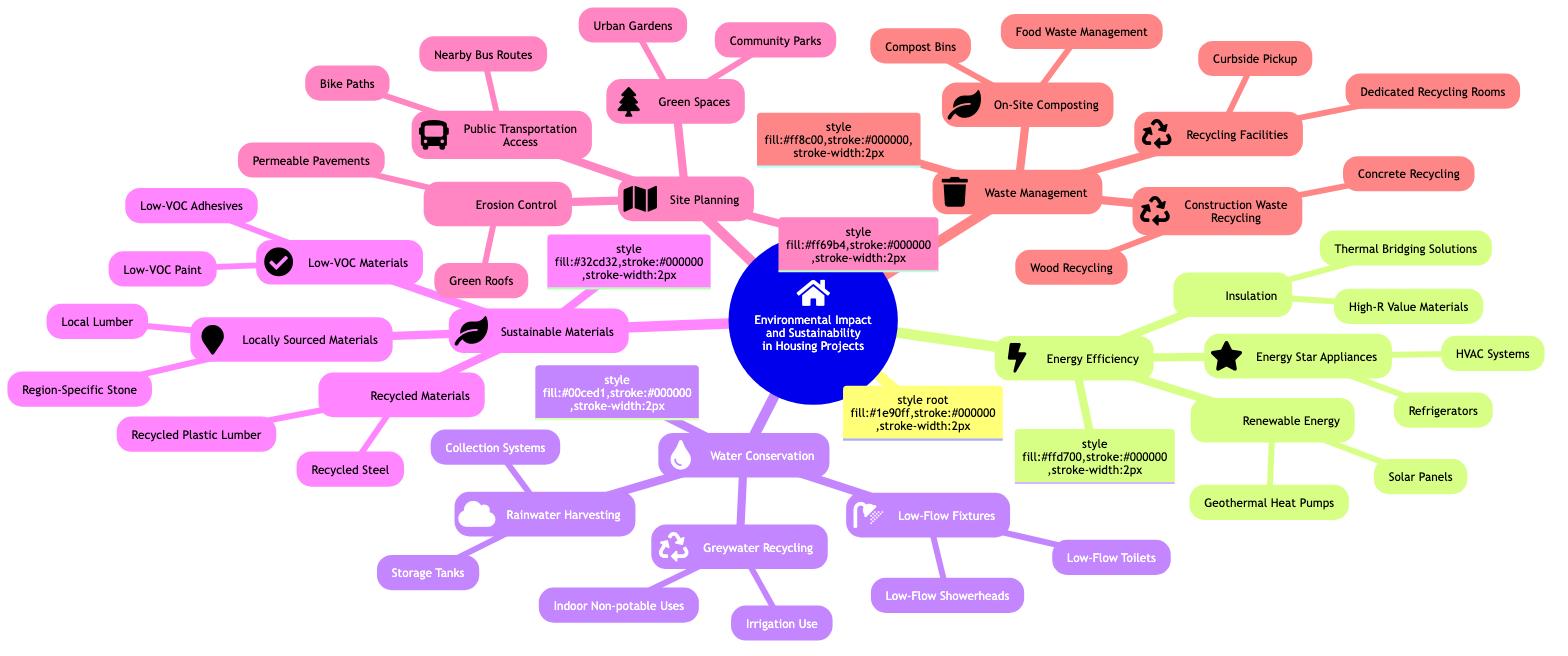What is the central topic of the mind map? The diagram explicitly states the central topic at the root node as "Environmental Impact and Sustainability in Housing Projects."
Answer: Environmental Impact and Sustainability in Housing Projects How many main branches does the diagram have? There are five main branches stemming from the central topic: Energy Efficiency, Water Conservation, Sustainable Materials, Site Planning, and Waste Management. Therefore, the count is five.
Answer: 5 What are two sub-branches of Water Conservation? Under the main branch Water Conservation, the sub-branches include Low-Flow Fixtures, Rainwater Harvesting, and Greywater Recycling. Two of these sub-branches are Low-Flow Fixtures and Rainwater Harvesting.
Answer: Low-Flow Fixtures, Rainwater Harvesting Which sub-branch includes “Solar Panels”? The sub-branch that includes "Solar Panels" is Renewable Energy, which falls under the main branch Energy Efficiency.
Answer: Renewable Energy How many types of water conservation techniques are mentioned? Under Water Conservation, the techniques listed include Low-Flow Fixtures, Rainwater Harvesting, and Greywater Recycling, giving a total of three different techniques.
Answer: 3 What does the Sustainable Materials branch emphasize regarding paint? Within the Sustainable Materials branch, the Low-VOC Materials sub-branch emphasizes the use of Low-VOC Paint.
Answer: Low-VOC Paint Which main branch has the most sub-branches? The main branch with the most sub-branches is Waste Management, which contains three sub-branches: Construction Waste Recycling, On-Site Composting, and Recycling Facilities, matching the count of others, but all have three.
Answer: Waste Management What relationship exists between Green Spaces and Urban Gardens? Urban Gardens is a specific example or sub-category under the broader concept of Green Spaces, making it a child node of that main branch.
Answer: Child node How many unique elements are listed under Sustainable Materials? The Sustainable Materials branch lists three unique sub-branches, each with examples: Recycled Materials, Locally Sourced Materials, and Low-VOC Materials, giving a count of six unique elements overall.
Answer: 6 